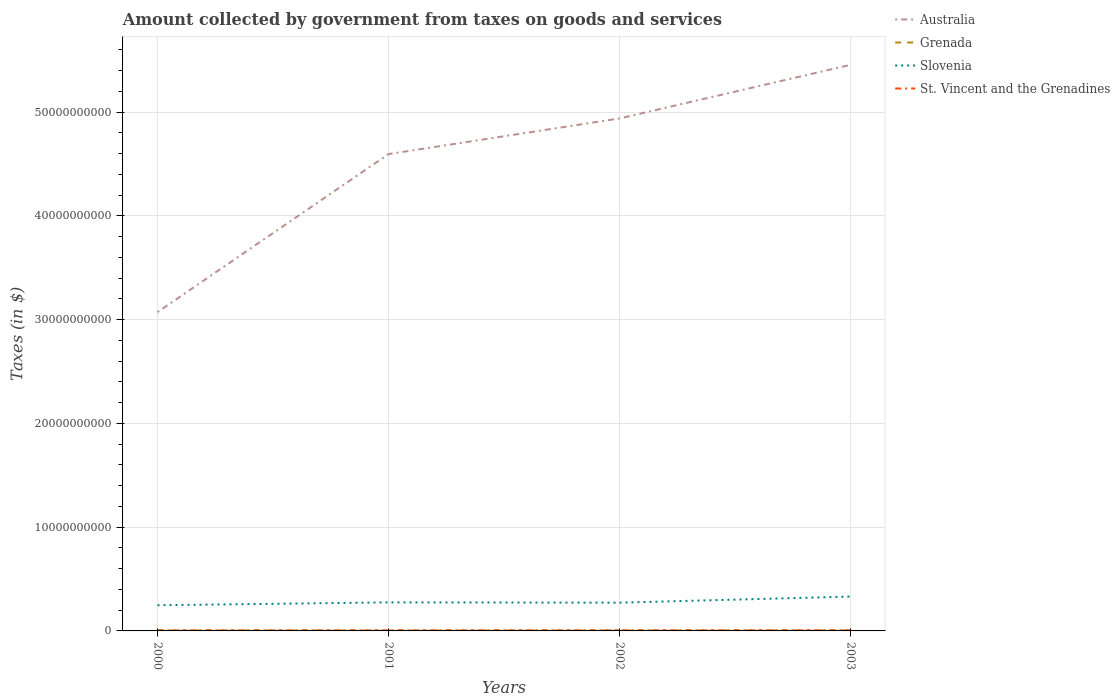How many different coloured lines are there?
Your answer should be very brief. 4. Does the line corresponding to Grenada intersect with the line corresponding to Slovenia?
Ensure brevity in your answer.  No. Across all years, what is the maximum amount collected by government from taxes on goods and services in Grenada?
Your answer should be compact. 4.49e+07. In which year was the amount collected by government from taxes on goods and services in St. Vincent and the Grenadines maximum?
Ensure brevity in your answer.  2000. What is the total amount collected by government from taxes on goods and services in St. Vincent and the Grenadines in the graph?
Give a very brief answer. -3.90e+06. What is the difference between the highest and the second highest amount collected by government from taxes on goods and services in Grenada?
Provide a short and direct response. 1.41e+07. How many years are there in the graph?
Keep it short and to the point. 4. Does the graph contain grids?
Your response must be concise. Yes. What is the title of the graph?
Offer a very short reply. Amount collected by government from taxes on goods and services. What is the label or title of the Y-axis?
Your answer should be compact. Taxes (in $). What is the Taxes (in $) in Australia in 2000?
Offer a terse response. 3.07e+1. What is the Taxes (in $) in Grenada in 2000?
Keep it short and to the point. 5.11e+07. What is the Taxes (in $) of Slovenia in 2000?
Give a very brief answer. 2.48e+09. What is the Taxes (in $) of St. Vincent and the Grenadines in 2000?
Provide a succinct answer. 5.15e+07. What is the Taxes (in $) of Australia in 2001?
Your response must be concise. 4.60e+1. What is the Taxes (in $) in Grenada in 2001?
Offer a terse response. 4.49e+07. What is the Taxes (in $) of Slovenia in 2001?
Your response must be concise. 2.75e+09. What is the Taxes (in $) in St. Vincent and the Grenadines in 2001?
Your answer should be very brief. 5.54e+07. What is the Taxes (in $) of Australia in 2002?
Keep it short and to the point. 4.94e+1. What is the Taxes (in $) of Grenada in 2002?
Provide a succinct answer. 4.96e+07. What is the Taxes (in $) of Slovenia in 2002?
Keep it short and to the point. 2.72e+09. What is the Taxes (in $) of St. Vincent and the Grenadines in 2002?
Keep it short and to the point. 5.58e+07. What is the Taxes (in $) of Australia in 2003?
Give a very brief answer. 5.46e+1. What is the Taxes (in $) in Grenada in 2003?
Keep it short and to the point. 5.90e+07. What is the Taxes (in $) of Slovenia in 2003?
Your answer should be compact. 3.31e+09. What is the Taxes (in $) of St. Vincent and the Grenadines in 2003?
Provide a short and direct response. 5.99e+07. Across all years, what is the maximum Taxes (in $) of Australia?
Keep it short and to the point. 5.46e+1. Across all years, what is the maximum Taxes (in $) of Grenada?
Ensure brevity in your answer.  5.90e+07. Across all years, what is the maximum Taxes (in $) in Slovenia?
Your response must be concise. 3.31e+09. Across all years, what is the maximum Taxes (in $) of St. Vincent and the Grenadines?
Make the answer very short. 5.99e+07. Across all years, what is the minimum Taxes (in $) in Australia?
Your answer should be compact. 3.07e+1. Across all years, what is the minimum Taxes (in $) of Grenada?
Offer a terse response. 4.49e+07. Across all years, what is the minimum Taxes (in $) in Slovenia?
Make the answer very short. 2.48e+09. Across all years, what is the minimum Taxes (in $) of St. Vincent and the Grenadines?
Your answer should be compact. 5.15e+07. What is the total Taxes (in $) of Australia in the graph?
Make the answer very short. 1.81e+11. What is the total Taxes (in $) in Grenada in the graph?
Your answer should be compact. 2.05e+08. What is the total Taxes (in $) in Slovenia in the graph?
Your response must be concise. 1.13e+1. What is the total Taxes (in $) of St. Vincent and the Grenadines in the graph?
Offer a terse response. 2.23e+08. What is the difference between the Taxes (in $) in Australia in 2000 and that in 2001?
Provide a short and direct response. -1.52e+1. What is the difference between the Taxes (in $) of Grenada in 2000 and that in 2001?
Give a very brief answer. 6.20e+06. What is the difference between the Taxes (in $) in Slovenia in 2000 and that in 2001?
Ensure brevity in your answer.  -2.75e+08. What is the difference between the Taxes (in $) in St. Vincent and the Grenadines in 2000 and that in 2001?
Offer a terse response. -3.90e+06. What is the difference between the Taxes (in $) in Australia in 2000 and that in 2002?
Provide a succinct answer. -1.87e+1. What is the difference between the Taxes (in $) of Grenada in 2000 and that in 2002?
Your response must be concise. 1.50e+06. What is the difference between the Taxes (in $) of Slovenia in 2000 and that in 2002?
Offer a terse response. -2.47e+08. What is the difference between the Taxes (in $) of St. Vincent and the Grenadines in 2000 and that in 2002?
Offer a very short reply. -4.30e+06. What is the difference between the Taxes (in $) of Australia in 2000 and that in 2003?
Your answer should be compact. -2.38e+1. What is the difference between the Taxes (in $) in Grenada in 2000 and that in 2003?
Keep it short and to the point. -7.90e+06. What is the difference between the Taxes (in $) in Slovenia in 2000 and that in 2003?
Your answer should be compact. -8.35e+08. What is the difference between the Taxes (in $) of St. Vincent and the Grenadines in 2000 and that in 2003?
Ensure brevity in your answer.  -8.40e+06. What is the difference between the Taxes (in $) of Australia in 2001 and that in 2002?
Your answer should be compact. -3.44e+09. What is the difference between the Taxes (in $) of Grenada in 2001 and that in 2002?
Provide a succinct answer. -4.70e+06. What is the difference between the Taxes (in $) of Slovenia in 2001 and that in 2002?
Provide a succinct answer. 2.84e+07. What is the difference between the Taxes (in $) of St. Vincent and the Grenadines in 2001 and that in 2002?
Your answer should be very brief. -4.00e+05. What is the difference between the Taxes (in $) of Australia in 2001 and that in 2003?
Ensure brevity in your answer.  -8.60e+09. What is the difference between the Taxes (in $) of Grenada in 2001 and that in 2003?
Your response must be concise. -1.41e+07. What is the difference between the Taxes (in $) in Slovenia in 2001 and that in 2003?
Your response must be concise. -5.60e+08. What is the difference between the Taxes (in $) in St. Vincent and the Grenadines in 2001 and that in 2003?
Provide a short and direct response. -4.50e+06. What is the difference between the Taxes (in $) of Australia in 2002 and that in 2003?
Your answer should be compact. -5.16e+09. What is the difference between the Taxes (in $) in Grenada in 2002 and that in 2003?
Offer a very short reply. -9.40e+06. What is the difference between the Taxes (in $) in Slovenia in 2002 and that in 2003?
Provide a short and direct response. -5.88e+08. What is the difference between the Taxes (in $) in St. Vincent and the Grenadines in 2002 and that in 2003?
Keep it short and to the point. -4.10e+06. What is the difference between the Taxes (in $) in Australia in 2000 and the Taxes (in $) in Grenada in 2001?
Provide a succinct answer. 3.07e+1. What is the difference between the Taxes (in $) in Australia in 2000 and the Taxes (in $) in Slovenia in 2001?
Offer a very short reply. 2.80e+1. What is the difference between the Taxes (in $) of Australia in 2000 and the Taxes (in $) of St. Vincent and the Grenadines in 2001?
Keep it short and to the point. 3.07e+1. What is the difference between the Taxes (in $) in Grenada in 2000 and the Taxes (in $) in Slovenia in 2001?
Make the answer very short. -2.70e+09. What is the difference between the Taxes (in $) of Grenada in 2000 and the Taxes (in $) of St. Vincent and the Grenadines in 2001?
Make the answer very short. -4.30e+06. What is the difference between the Taxes (in $) of Slovenia in 2000 and the Taxes (in $) of St. Vincent and the Grenadines in 2001?
Provide a succinct answer. 2.42e+09. What is the difference between the Taxes (in $) in Australia in 2000 and the Taxes (in $) in Grenada in 2002?
Provide a succinct answer. 3.07e+1. What is the difference between the Taxes (in $) of Australia in 2000 and the Taxes (in $) of Slovenia in 2002?
Keep it short and to the point. 2.80e+1. What is the difference between the Taxes (in $) of Australia in 2000 and the Taxes (in $) of St. Vincent and the Grenadines in 2002?
Your answer should be compact. 3.07e+1. What is the difference between the Taxes (in $) in Grenada in 2000 and the Taxes (in $) in Slovenia in 2002?
Offer a very short reply. -2.67e+09. What is the difference between the Taxes (in $) in Grenada in 2000 and the Taxes (in $) in St. Vincent and the Grenadines in 2002?
Your answer should be very brief. -4.70e+06. What is the difference between the Taxes (in $) in Slovenia in 2000 and the Taxes (in $) in St. Vincent and the Grenadines in 2002?
Your answer should be very brief. 2.42e+09. What is the difference between the Taxes (in $) in Australia in 2000 and the Taxes (in $) in Grenada in 2003?
Your response must be concise. 3.07e+1. What is the difference between the Taxes (in $) of Australia in 2000 and the Taxes (in $) of Slovenia in 2003?
Your response must be concise. 2.74e+1. What is the difference between the Taxes (in $) of Australia in 2000 and the Taxes (in $) of St. Vincent and the Grenadines in 2003?
Your answer should be very brief. 3.07e+1. What is the difference between the Taxes (in $) of Grenada in 2000 and the Taxes (in $) of Slovenia in 2003?
Provide a short and direct response. -3.26e+09. What is the difference between the Taxes (in $) of Grenada in 2000 and the Taxes (in $) of St. Vincent and the Grenadines in 2003?
Offer a terse response. -8.80e+06. What is the difference between the Taxes (in $) of Slovenia in 2000 and the Taxes (in $) of St. Vincent and the Grenadines in 2003?
Give a very brief answer. 2.42e+09. What is the difference between the Taxes (in $) in Australia in 2001 and the Taxes (in $) in Grenada in 2002?
Ensure brevity in your answer.  4.59e+1. What is the difference between the Taxes (in $) in Australia in 2001 and the Taxes (in $) in Slovenia in 2002?
Provide a short and direct response. 4.32e+1. What is the difference between the Taxes (in $) in Australia in 2001 and the Taxes (in $) in St. Vincent and the Grenadines in 2002?
Keep it short and to the point. 4.59e+1. What is the difference between the Taxes (in $) of Grenada in 2001 and the Taxes (in $) of Slovenia in 2002?
Provide a succinct answer. -2.68e+09. What is the difference between the Taxes (in $) in Grenada in 2001 and the Taxes (in $) in St. Vincent and the Grenadines in 2002?
Ensure brevity in your answer.  -1.09e+07. What is the difference between the Taxes (in $) of Slovenia in 2001 and the Taxes (in $) of St. Vincent and the Grenadines in 2002?
Your answer should be compact. 2.70e+09. What is the difference between the Taxes (in $) of Australia in 2001 and the Taxes (in $) of Grenada in 2003?
Offer a terse response. 4.59e+1. What is the difference between the Taxes (in $) of Australia in 2001 and the Taxes (in $) of Slovenia in 2003?
Give a very brief answer. 4.26e+1. What is the difference between the Taxes (in $) of Australia in 2001 and the Taxes (in $) of St. Vincent and the Grenadines in 2003?
Your answer should be compact. 4.59e+1. What is the difference between the Taxes (in $) in Grenada in 2001 and the Taxes (in $) in Slovenia in 2003?
Offer a terse response. -3.27e+09. What is the difference between the Taxes (in $) of Grenada in 2001 and the Taxes (in $) of St. Vincent and the Grenadines in 2003?
Provide a short and direct response. -1.50e+07. What is the difference between the Taxes (in $) of Slovenia in 2001 and the Taxes (in $) of St. Vincent and the Grenadines in 2003?
Keep it short and to the point. 2.69e+09. What is the difference between the Taxes (in $) of Australia in 2002 and the Taxes (in $) of Grenada in 2003?
Your answer should be compact. 4.93e+1. What is the difference between the Taxes (in $) in Australia in 2002 and the Taxes (in $) in Slovenia in 2003?
Give a very brief answer. 4.61e+1. What is the difference between the Taxes (in $) of Australia in 2002 and the Taxes (in $) of St. Vincent and the Grenadines in 2003?
Give a very brief answer. 4.93e+1. What is the difference between the Taxes (in $) in Grenada in 2002 and the Taxes (in $) in Slovenia in 2003?
Offer a terse response. -3.26e+09. What is the difference between the Taxes (in $) of Grenada in 2002 and the Taxes (in $) of St. Vincent and the Grenadines in 2003?
Ensure brevity in your answer.  -1.03e+07. What is the difference between the Taxes (in $) in Slovenia in 2002 and the Taxes (in $) in St. Vincent and the Grenadines in 2003?
Your answer should be compact. 2.66e+09. What is the average Taxes (in $) of Australia per year?
Give a very brief answer. 4.52e+1. What is the average Taxes (in $) in Grenada per year?
Keep it short and to the point. 5.12e+07. What is the average Taxes (in $) in Slovenia per year?
Offer a terse response. 2.82e+09. What is the average Taxes (in $) of St. Vincent and the Grenadines per year?
Provide a succinct answer. 5.56e+07. In the year 2000, what is the difference between the Taxes (in $) in Australia and Taxes (in $) in Grenada?
Keep it short and to the point. 3.07e+1. In the year 2000, what is the difference between the Taxes (in $) in Australia and Taxes (in $) in Slovenia?
Keep it short and to the point. 2.83e+1. In the year 2000, what is the difference between the Taxes (in $) in Australia and Taxes (in $) in St. Vincent and the Grenadines?
Give a very brief answer. 3.07e+1. In the year 2000, what is the difference between the Taxes (in $) in Grenada and Taxes (in $) in Slovenia?
Your response must be concise. -2.42e+09. In the year 2000, what is the difference between the Taxes (in $) in Grenada and Taxes (in $) in St. Vincent and the Grenadines?
Offer a terse response. -4.00e+05. In the year 2000, what is the difference between the Taxes (in $) in Slovenia and Taxes (in $) in St. Vincent and the Grenadines?
Give a very brief answer. 2.42e+09. In the year 2001, what is the difference between the Taxes (in $) in Australia and Taxes (in $) in Grenada?
Keep it short and to the point. 4.59e+1. In the year 2001, what is the difference between the Taxes (in $) in Australia and Taxes (in $) in Slovenia?
Provide a short and direct response. 4.32e+1. In the year 2001, what is the difference between the Taxes (in $) of Australia and Taxes (in $) of St. Vincent and the Grenadines?
Give a very brief answer. 4.59e+1. In the year 2001, what is the difference between the Taxes (in $) in Grenada and Taxes (in $) in Slovenia?
Keep it short and to the point. -2.71e+09. In the year 2001, what is the difference between the Taxes (in $) in Grenada and Taxes (in $) in St. Vincent and the Grenadines?
Your response must be concise. -1.05e+07. In the year 2001, what is the difference between the Taxes (in $) of Slovenia and Taxes (in $) of St. Vincent and the Grenadines?
Keep it short and to the point. 2.70e+09. In the year 2002, what is the difference between the Taxes (in $) of Australia and Taxes (in $) of Grenada?
Provide a succinct answer. 4.93e+1. In the year 2002, what is the difference between the Taxes (in $) in Australia and Taxes (in $) in Slovenia?
Ensure brevity in your answer.  4.67e+1. In the year 2002, what is the difference between the Taxes (in $) in Australia and Taxes (in $) in St. Vincent and the Grenadines?
Your answer should be very brief. 4.93e+1. In the year 2002, what is the difference between the Taxes (in $) of Grenada and Taxes (in $) of Slovenia?
Keep it short and to the point. -2.67e+09. In the year 2002, what is the difference between the Taxes (in $) in Grenada and Taxes (in $) in St. Vincent and the Grenadines?
Provide a succinct answer. -6.20e+06. In the year 2002, what is the difference between the Taxes (in $) of Slovenia and Taxes (in $) of St. Vincent and the Grenadines?
Provide a short and direct response. 2.67e+09. In the year 2003, what is the difference between the Taxes (in $) in Australia and Taxes (in $) in Grenada?
Give a very brief answer. 5.45e+1. In the year 2003, what is the difference between the Taxes (in $) of Australia and Taxes (in $) of Slovenia?
Provide a short and direct response. 5.12e+1. In the year 2003, what is the difference between the Taxes (in $) in Australia and Taxes (in $) in St. Vincent and the Grenadines?
Make the answer very short. 5.45e+1. In the year 2003, what is the difference between the Taxes (in $) of Grenada and Taxes (in $) of Slovenia?
Your response must be concise. -3.25e+09. In the year 2003, what is the difference between the Taxes (in $) of Grenada and Taxes (in $) of St. Vincent and the Grenadines?
Give a very brief answer. -9.00e+05. In the year 2003, what is the difference between the Taxes (in $) in Slovenia and Taxes (in $) in St. Vincent and the Grenadines?
Ensure brevity in your answer.  3.25e+09. What is the ratio of the Taxes (in $) of Australia in 2000 to that in 2001?
Offer a terse response. 0.67. What is the ratio of the Taxes (in $) of Grenada in 2000 to that in 2001?
Give a very brief answer. 1.14. What is the ratio of the Taxes (in $) in Slovenia in 2000 to that in 2001?
Your answer should be compact. 0.9. What is the ratio of the Taxes (in $) in St. Vincent and the Grenadines in 2000 to that in 2001?
Offer a terse response. 0.93. What is the ratio of the Taxes (in $) of Australia in 2000 to that in 2002?
Give a very brief answer. 0.62. What is the ratio of the Taxes (in $) in Grenada in 2000 to that in 2002?
Offer a very short reply. 1.03. What is the ratio of the Taxes (in $) of Slovenia in 2000 to that in 2002?
Offer a very short reply. 0.91. What is the ratio of the Taxes (in $) in St. Vincent and the Grenadines in 2000 to that in 2002?
Your response must be concise. 0.92. What is the ratio of the Taxes (in $) of Australia in 2000 to that in 2003?
Your answer should be compact. 0.56. What is the ratio of the Taxes (in $) of Grenada in 2000 to that in 2003?
Provide a short and direct response. 0.87. What is the ratio of the Taxes (in $) in Slovenia in 2000 to that in 2003?
Provide a short and direct response. 0.75. What is the ratio of the Taxes (in $) of St. Vincent and the Grenadines in 2000 to that in 2003?
Your answer should be compact. 0.86. What is the ratio of the Taxes (in $) of Australia in 2001 to that in 2002?
Give a very brief answer. 0.93. What is the ratio of the Taxes (in $) of Grenada in 2001 to that in 2002?
Your answer should be very brief. 0.91. What is the ratio of the Taxes (in $) of Slovenia in 2001 to that in 2002?
Make the answer very short. 1.01. What is the ratio of the Taxes (in $) of Australia in 2001 to that in 2003?
Offer a very short reply. 0.84. What is the ratio of the Taxes (in $) in Grenada in 2001 to that in 2003?
Your response must be concise. 0.76. What is the ratio of the Taxes (in $) in Slovenia in 2001 to that in 2003?
Your answer should be very brief. 0.83. What is the ratio of the Taxes (in $) of St. Vincent and the Grenadines in 2001 to that in 2003?
Your answer should be very brief. 0.92. What is the ratio of the Taxes (in $) of Australia in 2002 to that in 2003?
Provide a short and direct response. 0.91. What is the ratio of the Taxes (in $) in Grenada in 2002 to that in 2003?
Give a very brief answer. 0.84. What is the ratio of the Taxes (in $) of Slovenia in 2002 to that in 2003?
Offer a very short reply. 0.82. What is the ratio of the Taxes (in $) of St. Vincent and the Grenadines in 2002 to that in 2003?
Offer a terse response. 0.93. What is the difference between the highest and the second highest Taxes (in $) in Australia?
Offer a terse response. 5.16e+09. What is the difference between the highest and the second highest Taxes (in $) in Grenada?
Your response must be concise. 7.90e+06. What is the difference between the highest and the second highest Taxes (in $) of Slovenia?
Your answer should be compact. 5.60e+08. What is the difference between the highest and the second highest Taxes (in $) of St. Vincent and the Grenadines?
Your answer should be compact. 4.10e+06. What is the difference between the highest and the lowest Taxes (in $) in Australia?
Keep it short and to the point. 2.38e+1. What is the difference between the highest and the lowest Taxes (in $) in Grenada?
Make the answer very short. 1.41e+07. What is the difference between the highest and the lowest Taxes (in $) in Slovenia?
Offer a very short reply. 8.35e+08. What is the difference between the highest and the lowest Taxes (in $) in St. Vincent and the Grenadines?
Offer a very short reply. 8.40e+06. 